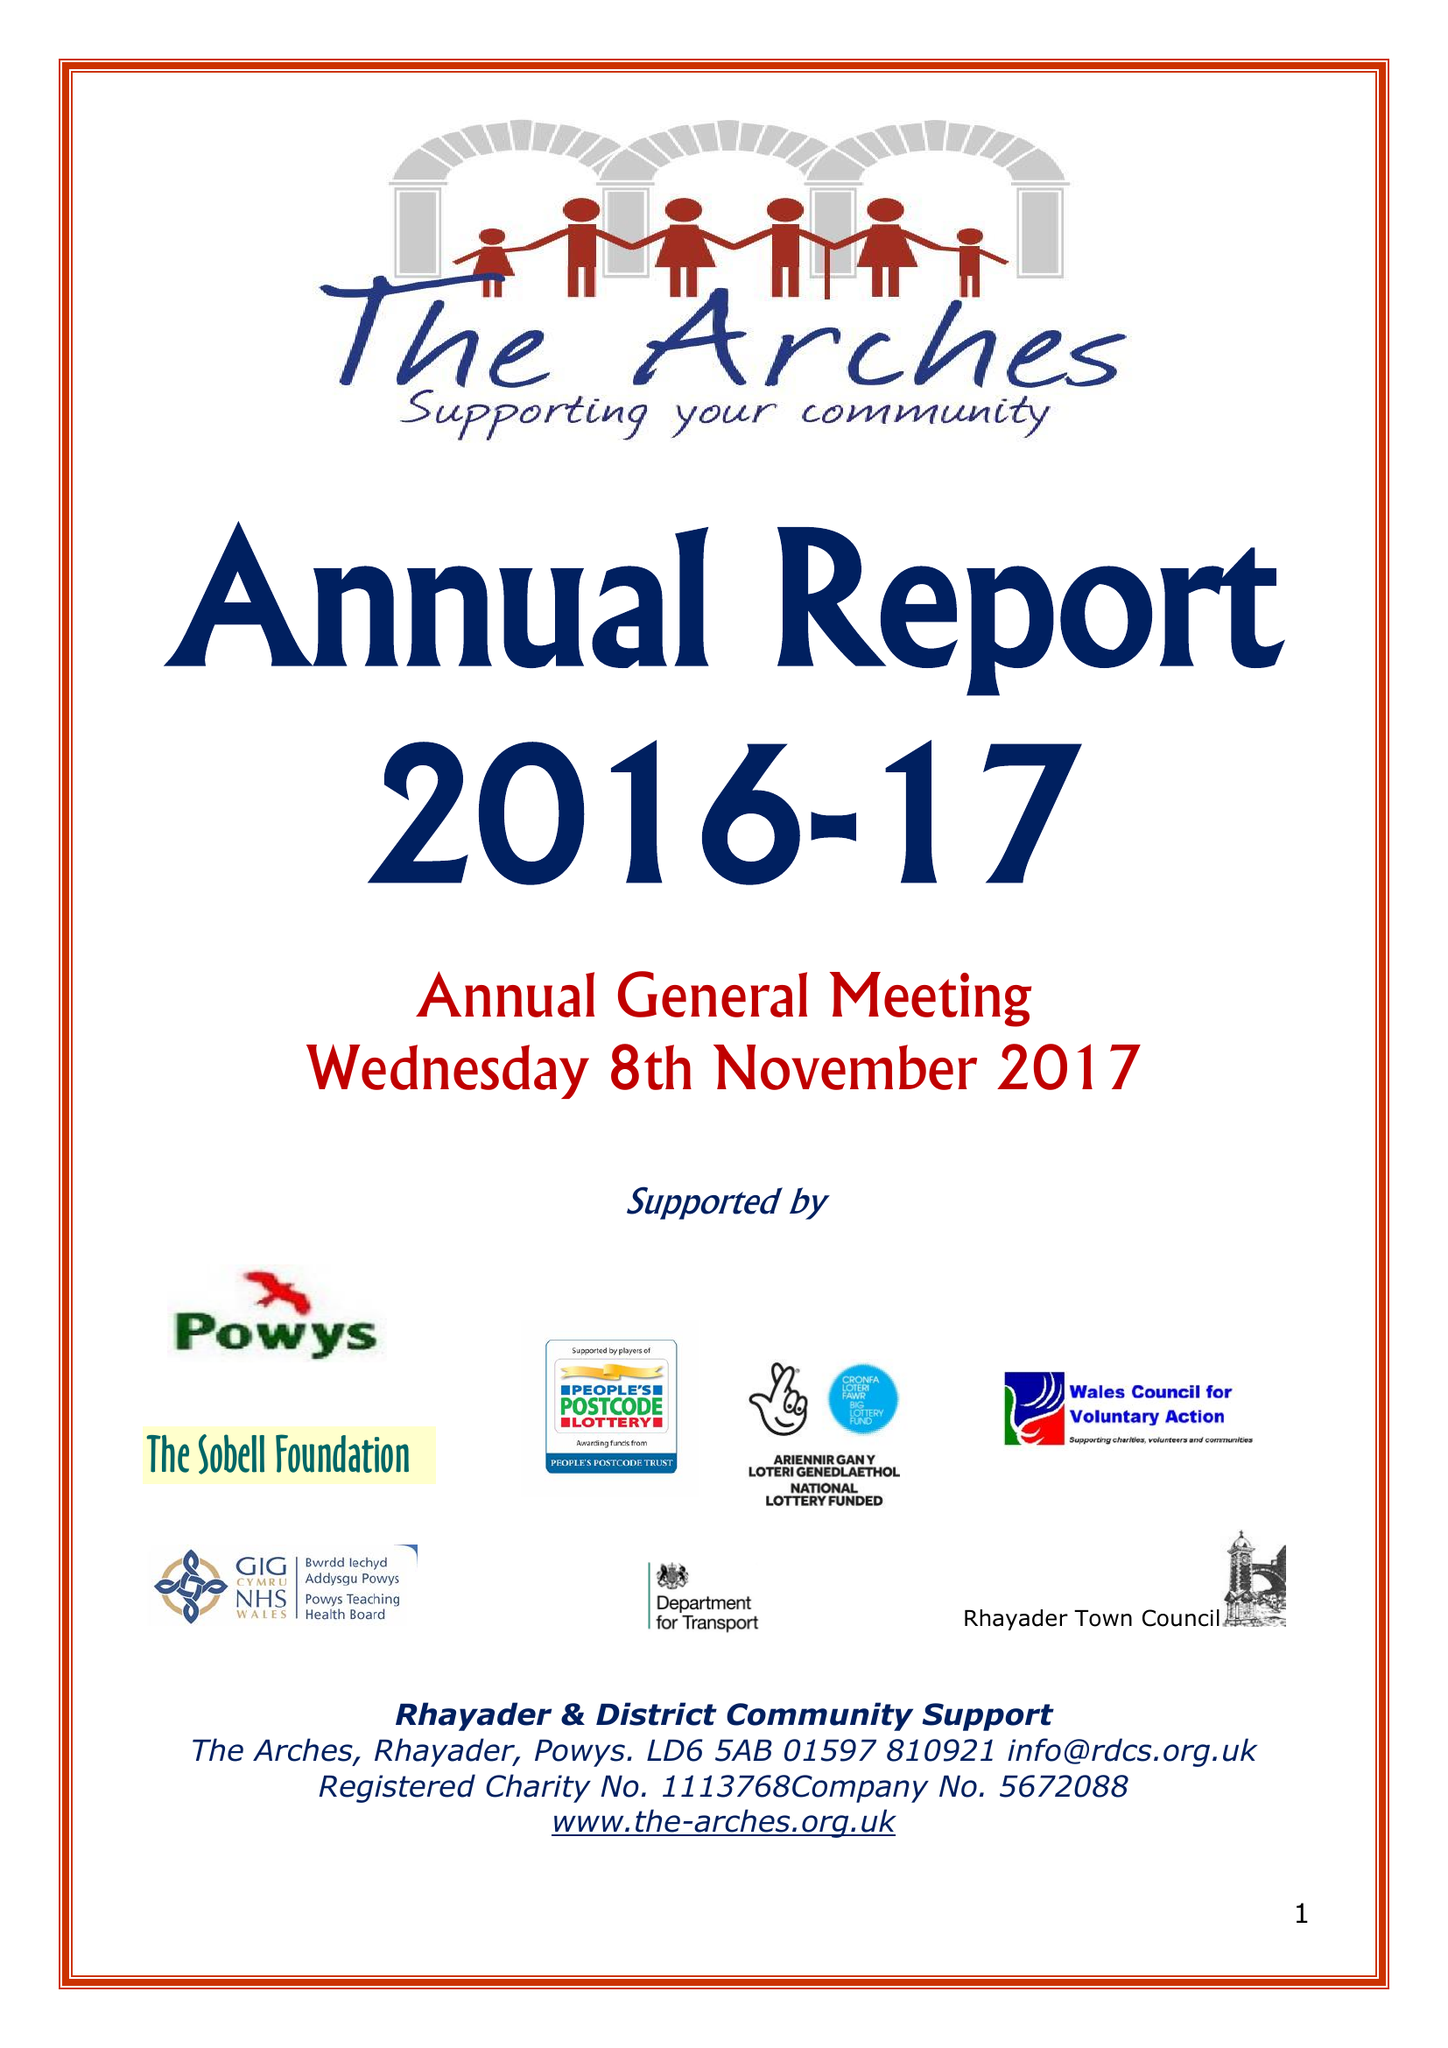What is the value for the charity_name?
Answer the question using a single word or phrase. Rhayader and District Community Support Ltd. 